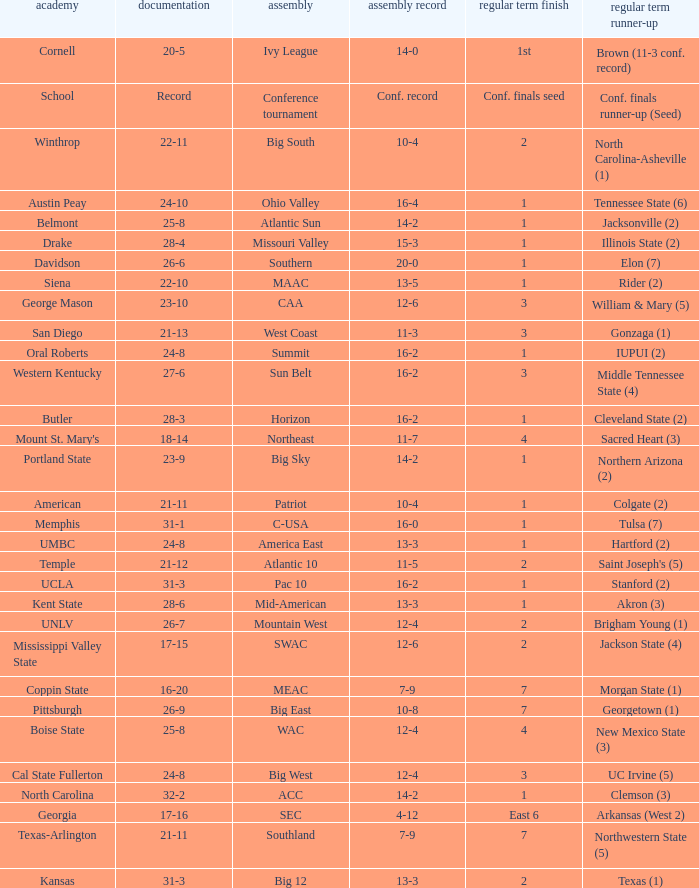What was the overall record of Oral Roberts college? 24-8. Would you be able to parse every entry in this table? {'header': ['academy', 'documentation', 'assembly', 'assembly record', 'regular term finish', 'regular term runner-up'], 'rows': [['Cornell', '20-5', 'Ivy League', '14-0', '1st', 'Brown (11-3 conf. record)'], ['School', 'Record', 'Conference tournament', 'Conf. record', 'Conf. finals seed', 'Conf. finals runner-up (Seed)'], ['Winthrop', '22-11', 'Big South', '10-4', '2', 'North Carolina-Asheville (1)'], ['Austin Peay', '24-10', 'Ohio Valley', '16-4', '1', 'Tennessee State (6)'], ['Belmont', '25-8', 'Atlantic Sun', '14-2', '1', 'Jacksonville (2)'], ['Drake', '28-4', 'Missouri Valley', '15-3', '1', 'Illinois State (2)'], ['Davidson', '26-6', 'Southern', '20-0', '1', 'Elon (7)'], ['Siena', '22-10', 'MAAC', '13-5', '1', 'Rider (2)'], ['George Mason', '23-10', 'CAA', '12-6', '3', 'William & Mary (5)'], ['San Diego', '21-13', 'West Coast', '11-3', '3', 'Gonzaga (1)'], ['Oral Roberts', '24-8', 'Summit', '16-2', '1', 'IUPUI (2)'], ['Western Kentucky', '27-6', 'Sun Belt', '16-2', '3', 'Middle Tennessee State (4)'], ['Butler', '28-3', 'Horizon', '16-2', '1', 'Cleveland State (2)'], ["Mount St. Mary's", '18-14', 'Northeast', '11-7', '4', 'Sacred Heart (3)'], ['Portland State', '23-9', 'Big Sky', '14-2', '1', 'Northern Arizona (2)'], ['American', '21-11', 'Patriot', '10-4', '1', 'Colgate (2)'], ['Memphis', '31-1', 'C-USA', '16-0', '1', 'Tulsa (7)'], ['UMBC', '24-8', 'America East', '13-3', '1', 'Hartford (2)'], ['Temple', '21-12', 'Atlantic 10', '11-5', '2', "Saint Joseph's (5)"], ['UCLA', '31-3', 'Pac 10', '16-2', '1', 'Stanford (2)'], ['Kent State', '28-6', 'Mid-American', '13-3', '1', 'Akron (3)'], ['UNLV', '26-7', 'Mountain West', '12-4', '2', 'Brigham Young (1)'], ['Mississippi Valley State', '17-15', 'SWAC', '12-6', '2', 'Jackson State (4)'], ['Coppin State', '16-20', 'MEAC', '7-9', '7', 'Morgan State (1)'], ['Pittsburgh', '26-9', 'Big East', '10-8', '7', 'Georgetown (1)'], ['Boise State', '25-8', 'WAC', '12-4', '4', 'New Mexico State (3)'], ['Cal State Fullerton', '24-8', 'Big West', '12-4', '3', 'UC Irvine (5)'], ['North Carolina', '32-2', 'ACC', '14-2', '1', 'Clemson (3)'], ['Georgia', '17-16', 'SEC', '4-12', 'East 6', 'Arkansas (West 2)'], ['Texas-Arlington', '21-11', 'Southland', '7-9', '7', 'Northwestern State (5)'], ['Kansas', '31-3', 'Big 12', '13-3', '2', 'Texas (1)']]} 